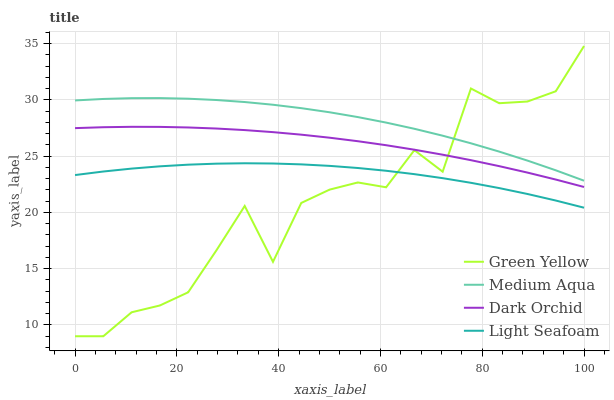Does Medium Aqua have the minimum area under the curve?
Answer yes or no. No. Does Green Yellow have the maximum area under the curve?
Answer yes or no. No. Is Medium Aqua the smoothest?
Answer yes or no. No. Is Medium Aqua the roughest?
Answer yes or no. No. Does Medium Aqua have the lowest value?
Answer yes or no. No. Does Medium Aqua have the highest value?
Answer yes or no. No. Is Dark Orchid less than Medium Aqua?
Answer yes or no. Yes. Is Dark Orchid greater than Light Seafoam?
Answer yes or no. Yes. Does Dark Orchid intersect Medium Aqua?
Answer yes or no. No. 